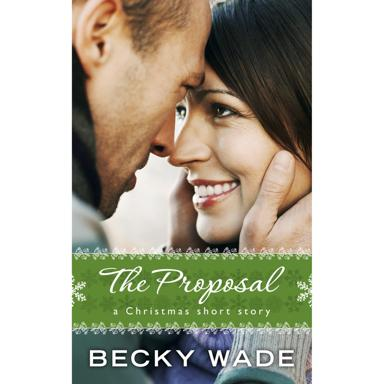What is the title and author of the short story mentioned in the image? The image features the cover of a Christmas short story titled 'The Proposal,' written by renowned author Becky Wade. It showcases a tender moment between a couple, indicating a romantic theme that is likely central to the story's narrative. 